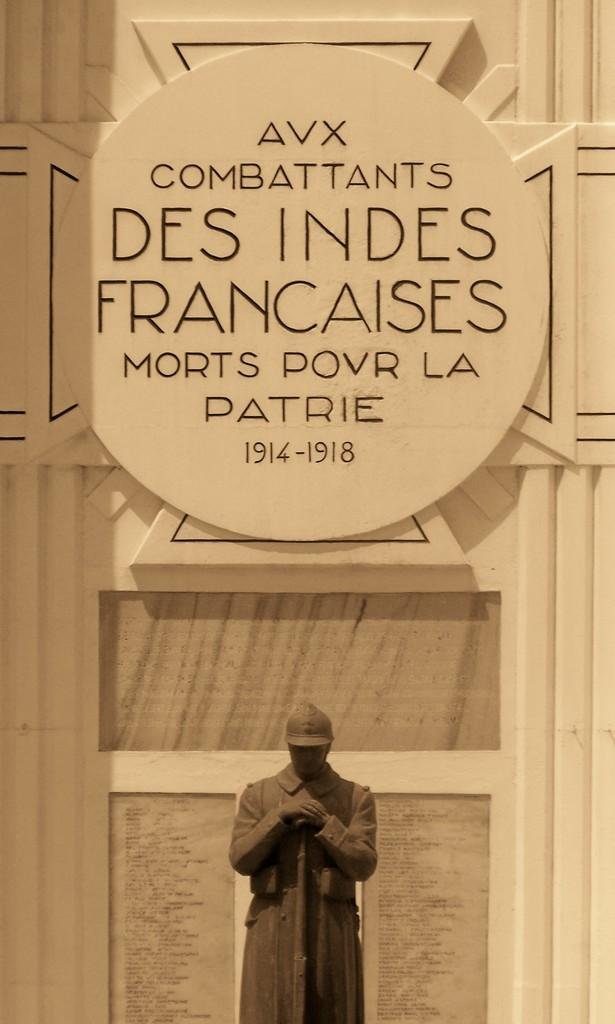What is the main subject of the image? There is a statue of a person in the image. What is the statue holding? The statue is holding a gun. How is the statue holding the gun? The statue has both hands on the gun. What can be seen in the background of the image? There is a hoarding on the wall in the background of the image. What type of glue is being used to attach the statue to the wall in the image? There is no glue present in the image, and the statue is not attached to the wall. 